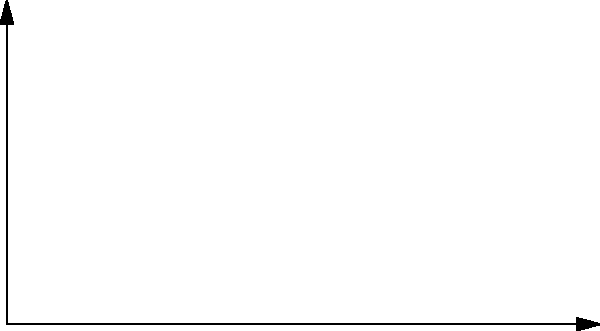In a dynamic tracking shot, a camera moves through a series of positions represented by the points $P_1$ to $P_5$ in the 2D coordinate system shown above. The x-axis represents horizontal movement, and the y-axis represents vertical movement, both measured in meters. Calculate the total displacement vector of the camera from its initial position $P_1$ to its final position $P_5$. To find the total displacement vector, we need to follow these steps:

1. Identify the initial and final positions:
   $P_1 = (0, 0)$
   $P_5 = (10, 5)$

2. Calculate the displacement vector by subtracting the initial position from the final position:
   $\vec{D} = P_5 - P_1 = (10, 5) - (0, 0) = (10, 5)$

3. The displacement vector $\vec{D} = (10, 5)$ represents:
   - 10 meters of horizontal movement to the right
   - 5 meters of vertical movement upward

4. We can express this vector in component form:
   $\vec{D} = 10\hat{i} + 5\hat{j}$

   Where $\hat{i}$ is the unit vector in the x-direction and $\hat{j}$ is the unit vector in the y-direction.

5. The magnitude of the displacement vector can be calculated using the Pythagorean theorem:
   $|\vec{D}| = \sqrt{10^2 + 5^2} = \sqrt{125} \approx 11.18$ meters

However, the question asks for the displacement vector, not its magnitude.
Answer: $\vec{D} = 10\hat{i} + 5\hat{j}$ 